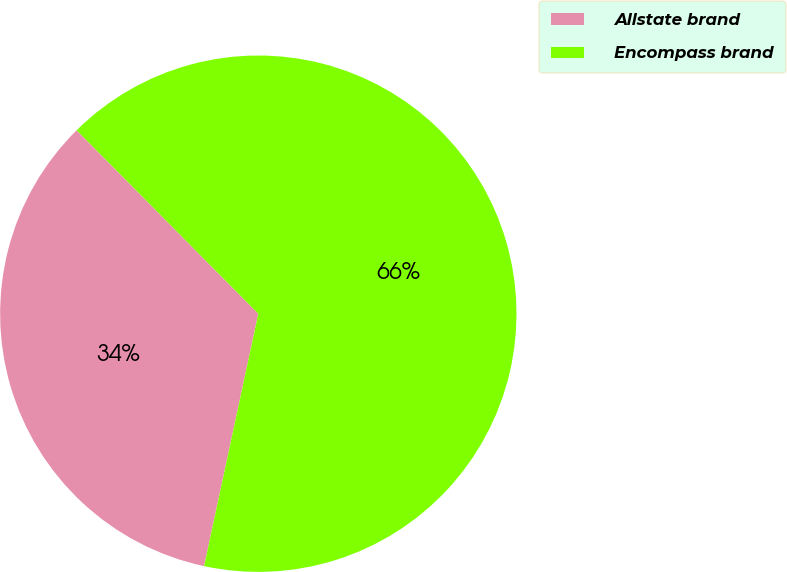<chart> <loc_0><loc_0><loc_500><loc_500><pie_chart><fcel>Allstate brand<fcel>Encompass brand<nl><fcel>34.21%<fcel>65.79%<nl></chart> 